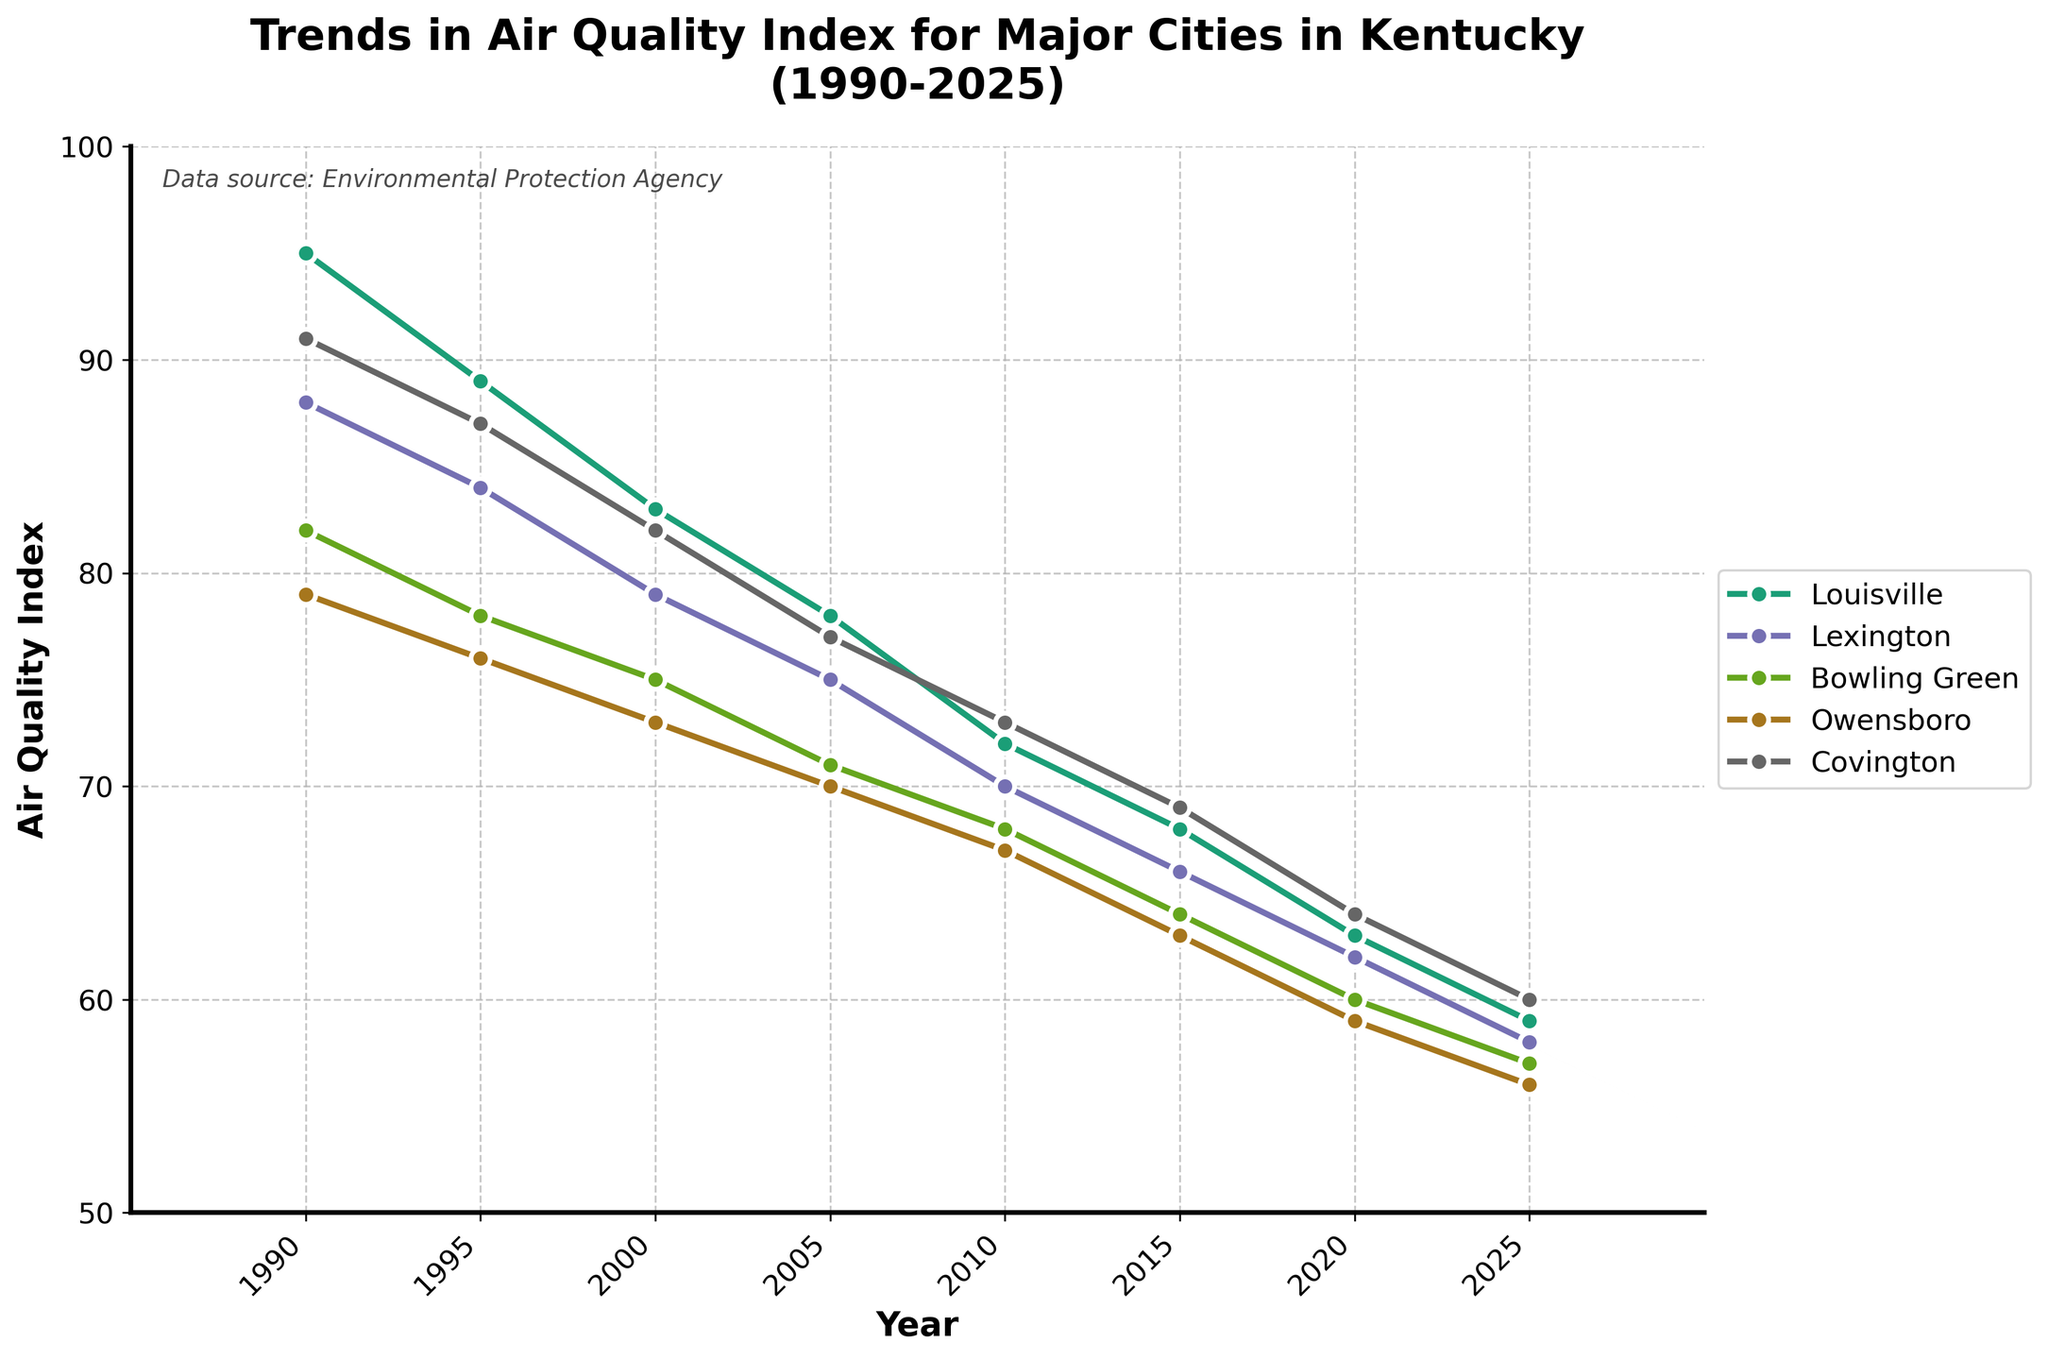Which city has the sharpest decline in the Air Quality Index from 1990 to 2025? To find the city with the sharpest decline, we need to calculate the difference in the Air Quality Index for each city between the years 1990 and 2025. Louisville: 95-59=36, Lexington: 88-58=30, Bowling Green: 82-57=25, Owensboro: 79-56=23, Covington: 91-60=31. Louisville has the greatest decline of 36 points.
Answer: Louisville Which city had the highest Air Quality Index in 2000? Reviewing the Air Quality Index values for each city in the year 2000, we have Louisville: 83, Lexington: 79, Bowling Green: 75, Owensboro: 73, Covington: 82. Louisville has the highest value at 83.
Answer: Louisville How did the Air Quality Index of Lexington change between 1990 and 2010? To determine the change, subtract the 2010 value from the 1990 value for Lexington. The calculation is 88 - 70 = 18.
Answer: Decreased by 18 What is the average Air Quality Index of Bowling Green from 1990 to 2025? The values for Bowling Green from 1990 to 2025 are: 82, 78, 75, 71, 68, 64, 60, 57. Sum these values: 82 + 78 + 75 + 71 + 68 + 64 + 60 + 57 = 555. The average is 555 / 8 = 69.375.
Answer: 69.375 Between Owensboro and Covington, which city had the lower Air Quality Index in 2020? Comparing the values for 2020, Owensboro: 59, and Covington: 64, Owensboro has the lower Air Quality Index.
Answer: Owensboro What is the overall trend in the Air Quality Index for all cities from 1990 to 2025? Observing the trends for all cities, each one shows a consistent decline in the Air Quality Index over the years. This indicates an overall improvement in air quality in all major cities in Kentucky from 1990 to 2025.
Answer: Overall decline Which city showed the most consistent decrease in Air Quality Index over the years? To find the most consistent decrease, we compare the decreases at regular intervals and their closeness to each other. All cities show a rather consistent decline, but Covington exhibits a very regular and smooth decline from 91 in 1990 to 60 in 2025.
Answer: Covington In 2015, which city had the lowest Air Quality Index and what was the value? Checking the Air Quality Index values for 2015, Louisville: 68, Lexington: 66, Bowling Green: 64, Owensboro: 63, Covington: 69. Owensboro has the lowest value at 63.
Answer: Owensboro with 63 